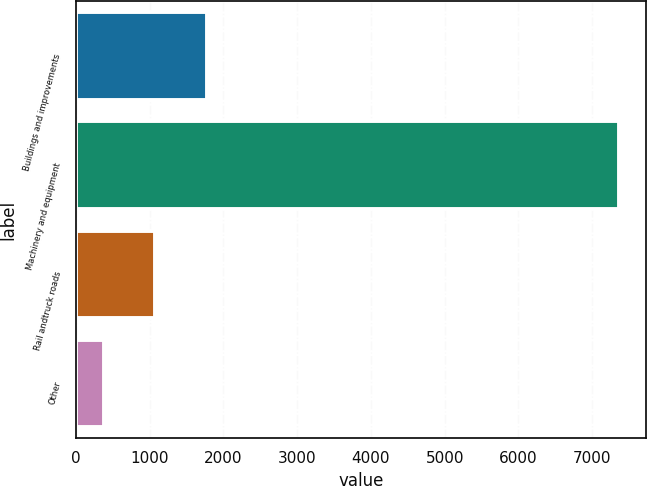<chart> <loc_0><loc_0><loc_500><loc_500><bar_chart><fcel>Buildings and improvements<fcel>Machinery and equipment<fcel>Rail andtruck roads<fcel>Other<nl><fcel>1776.4<fcel>7358<fcel>1078.7<fcel>381<nl></chart> 